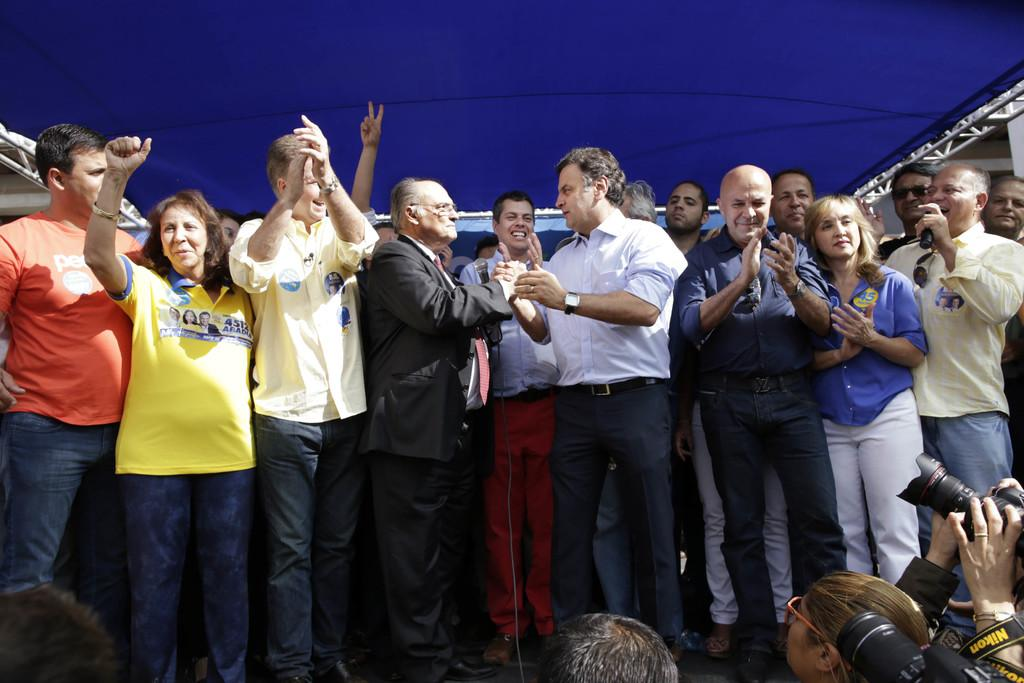What is happening in the image involving the group of people? There is a man holding a microphone, which suggests that the group of people might be participating in an event or gathering. What can be seen in the hands of the man? The man is holding a microphone. What objects are visible in the image that are related to recording or capturing the event? There are cameras visible in the image. What can be seen in the background of the image? There are wires and a rooftop visible in the background of the image. What is the color of the sky in the image? The sky is blue in color. What type of punishment is being handed out to the people in the image? There is no indication of punishment in the image; the man holding the microphone suggests a gathering or event. How much money is being exchanged between the people in the image? There is no mention of money or any financial transactions in the image. 